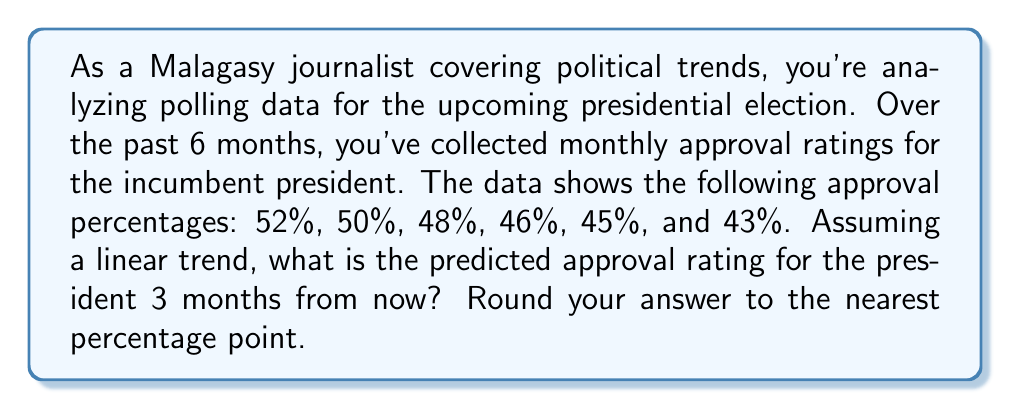Could you help me with this problem? To solve this problem, we'll use linear regression to analyze the trend and make a prediction. Here's a step-by-step approach:

1. Assign time values (x) to each month, starting with 0 for the first month:
   x: 0, 1, 2, 3, 4, 5
   y: 52, 50, 48, 46, 45, 43

2. Calculate the means of x and y:
   $\bar{x} = \frac{0 + 1 + 2 + 3 + 4 + 5}{6} = 2.5$
   $\bar{y} = \frac{52 + 50 + 48 + 46 + 45 + 43}{6} = 47.33$

3. Calculate the slope (m) using the formula:
   $$m = \frac{\sum(x - \bar{x})(y - \bar{y})}{\sum(x - \bar{x})^2}$$

4. Calculate the y-intercept (b) using the formula:
   $$b = \bar{y} - m\bar{x}$$

5. Plugging in the values:
   $$m = \frac{(-2.5)(4.67) + (-1.5)(2.67) + (-0.5)(0.67) + (0.5)(-1.33) + (1.5)(-2.33) + (2.5)(-4.33)}{(-2.5)^2 + (-1.5)^2 + (-0.5)^2 + (0.5)^2 + (1.5)^2 + (2.5)^2} = -1.80$$

   $$b = 47.33 - (-1.80)(2.5) = 51.83$$

6. The linear equation is:
   $$y = -1.80x + 51.83$$

7. To predict the approval rating 3 months from now, we use x = 8 (5 + 3):
   $$y = -1.80(8) + 51.83 = 37.43$$

8. Rounding to the nearest percentage point:
   37.43 ≈ 37%
Answer: 37% 